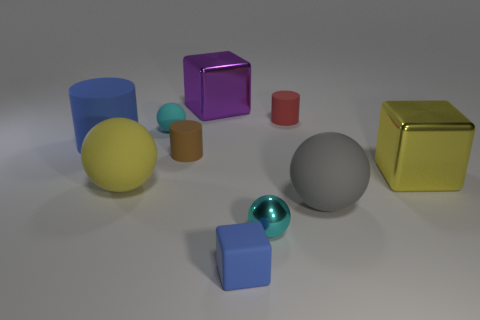Is the number of large purple blocks less than the number of blue metal spheres?
Your answer should be very brief. No. There is a small rubber thing in front of the cyan thing right of the tiny blue cube; what shape is it?
Offer a terse response. Cube. There is a big purple block; are there any purple cubes in front of it?
Give a very brief answer. No. What is the color of the other rubber cylinder that is the same size as the brown cylinder?
Offer a very short reply. Red. What number of large purple things have the same material as the red thing?
Your answer should be very brief. 0. What number of other things are the same size as the gray matte ball?
Ensure brevity in your answer.  4. Are there any purple shiny balls that have the same size as the brown rubber thing?
Ensure brevity in your answer.  No. Is the color of the big rubber cylinder in front of the small red object the same as the tiny cube?
Your answer should be very brief. Yes. How many objects are blue cubes or brown things?
Ensure brevity in your answer.  2. Is the size of the cyan object on the left side of the metallic ball the same as the yellow ball?
Your answer should be compact. No. 